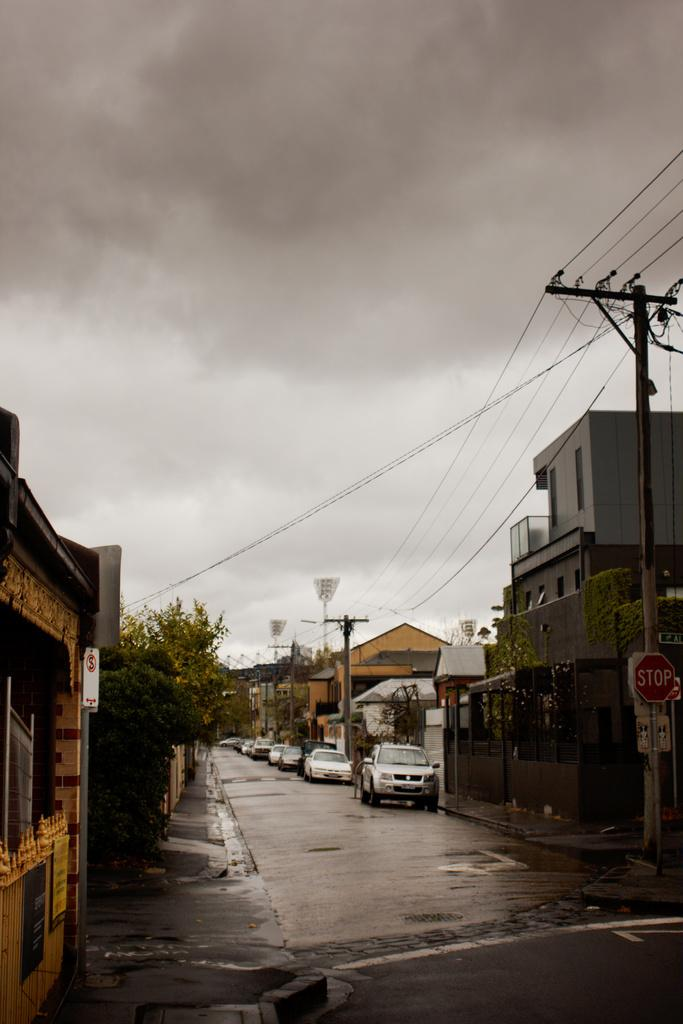What can be seen on the road in the image? There are vehicles on the road in the image. What structures are present near the road? There are electric poles in the image. What colors are the buildings in the image? The buildings in the image are in brown and gray colors. What type of vegetation is present in the image? There are trees in green color in the image. What is the color of the sky in the image? The sky is in white and gray color in the image. Can you tell me the time on the clock in the image? There is no clock present in the image. What type of tray is used to serve food in the image? There is no tray present in the image. 